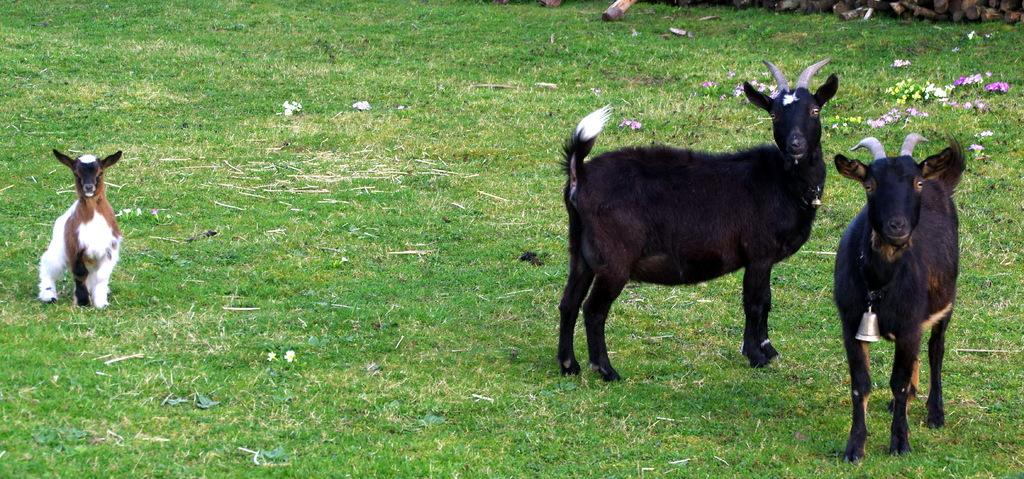What type of vegetation is present in the image? There is grass in the image. What animals can be seen in the image? There are goats in the image. Where are the flowers located in the image? The flowers are in the top right corner of the image. What type of button can be seen on the goat's collar in the image? There is no button or collar visible on the goats in the image. How many corn plants are growing in the grass in the image? There is no corn visible in the image; only grass, goats, and flowers are shown. 